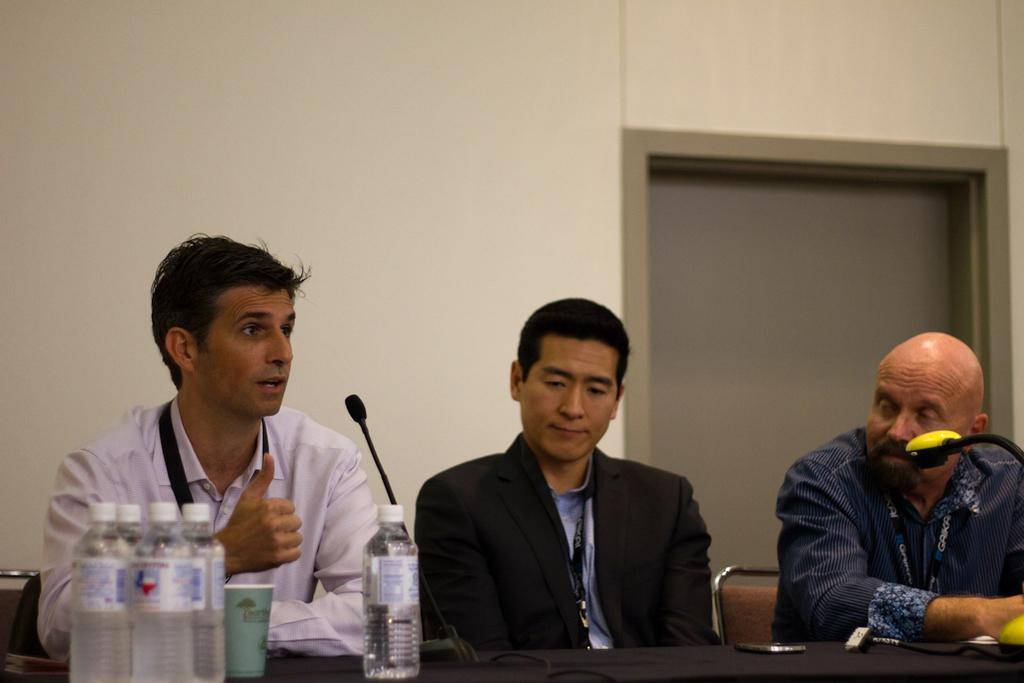What is located at the bottom of the image? There is a table at the bottom of the image. What objects are on the table? There are bottles, cups, and microphones on the table. Who is present in the image? There are people sitting behind the table. What can be seen behind the people? There is a wall visible behind the people. What type of plantation can be seen in the image? There is no plantation present in the image. What is the reason for the people saying good-bye in the image? There is no indication in the image that the people are saying good-bye. Can you tell me how many apples are on the table? There are no apples present on the table in the image. 